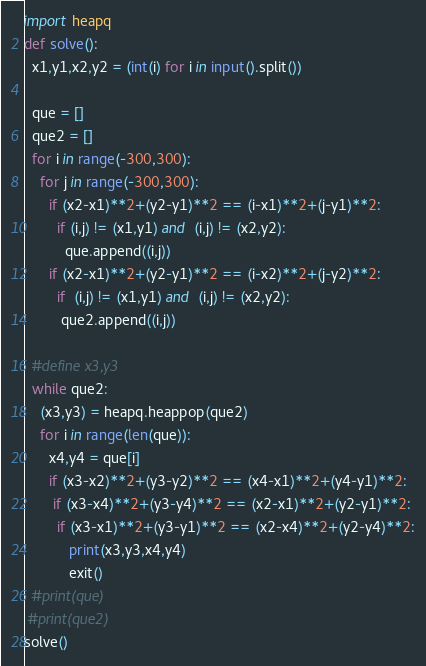<code> <loc_0><loc_0><loc_500><loc_500><_Python_>import heapq
def solve():
  x1,y1,x2,y2 = (int(i) for i in input().split())
  
  que = []
  que2 = []
  for i in range(-300,300):
    for j in range(-300,300):
      if (x2-x1)**2+(y2-y1)**2 == (i-x1)**2+(j-y1)**2:
        if (i,j) != (x1,y1) and  (i,j) != (x2,y2):
          que.append((i,j))
      if (x2-x1)**2+(y2-y1)**2 == (i-x2)**2+(j-y2)**2:
        if  (i,j) != (x1,y1) and  (i,j) != (x2,y2):
         que2.append((i,j))
        
  #define x3,y3
  while que2:
    (x3,y3) = heapq.heappop(que2)
    for i in range(len(que)):
      x4,y4 = que[i]
      if (x3-x2)**2+(y3-y2)**2 == (x4-x1)**2+(y4-y1)**2:
       if (x3-x4)**2+(y3-y4)**2 == (x2-x1)**2+(y2-y1)**2:
        if (x3-x1)**2+(y3-y1)**2 == (x2-x4)**2+(y2-y4)**2:
           print(x3,y3,x4,y4)
           exit()
  #print(que)
 #print(que2)			
solve()</code> 